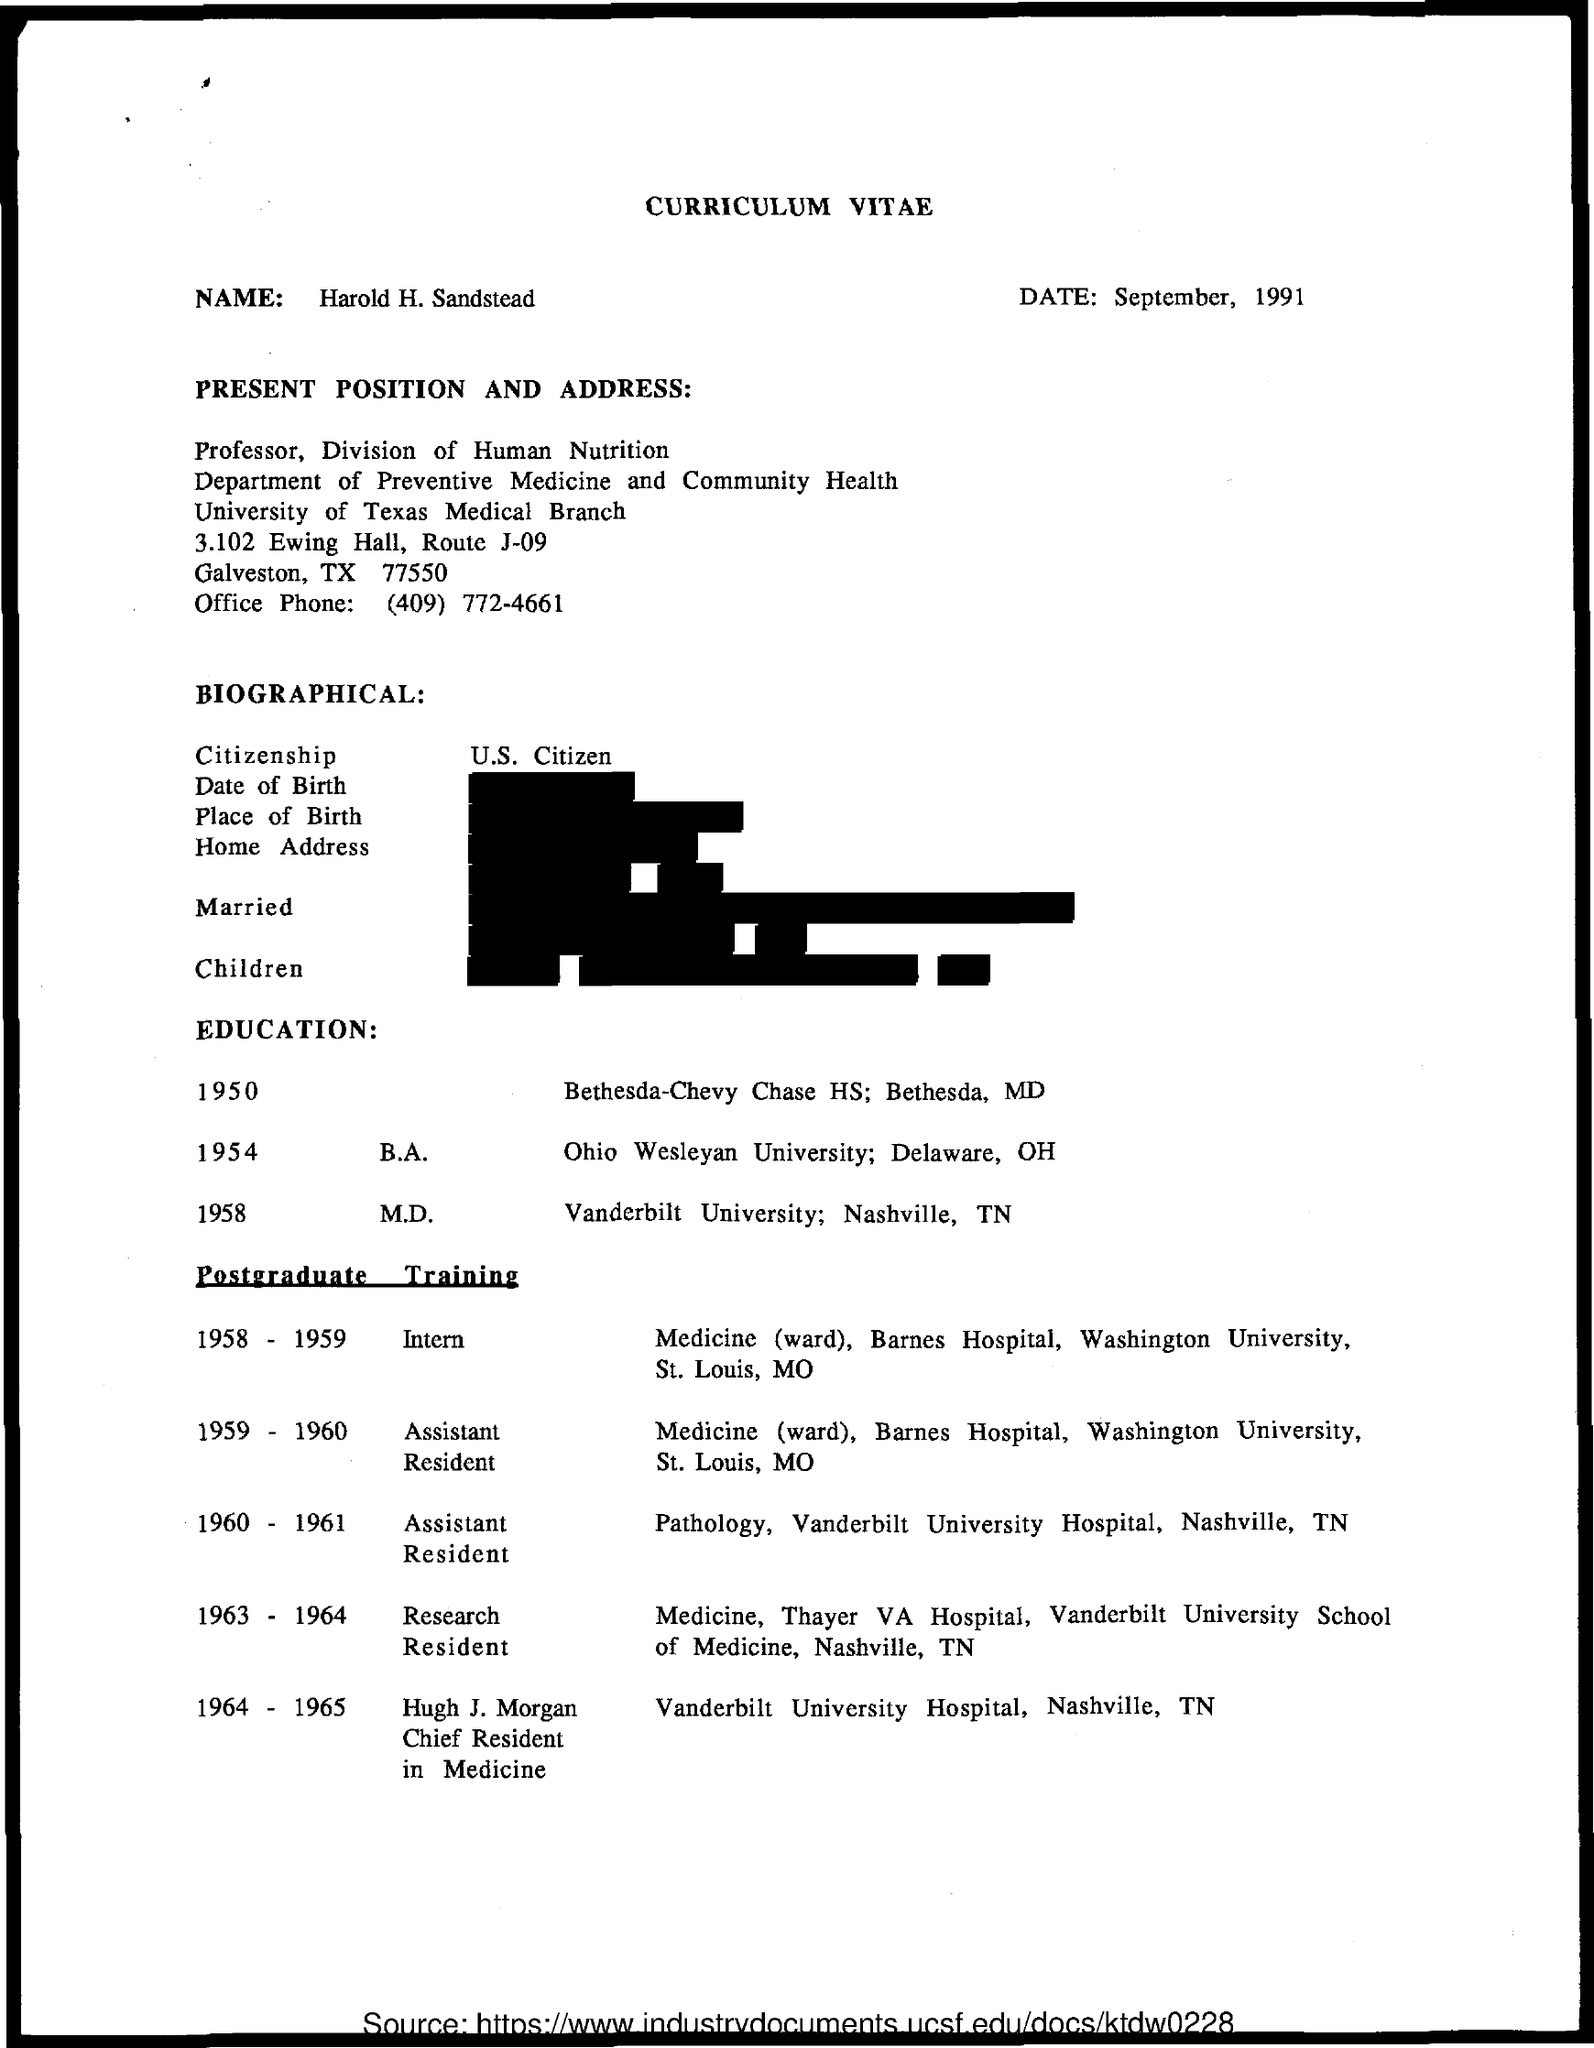What is the Title of the document?
Offer a very short reply. Curriculum Vitae. What is the Name?
Provide a short and direct response. Harold H. Sandstead. What is the Date?
Your answer should be very brief. September, 1991. What is the Citizenship?
Offer a very short reply. U.S. Citizen. When was he an intern?
Your answer should be compact. 1958 - 1959. When was he a Reseach Resident?
Keep it short and to the point. 1963 - 1964. 